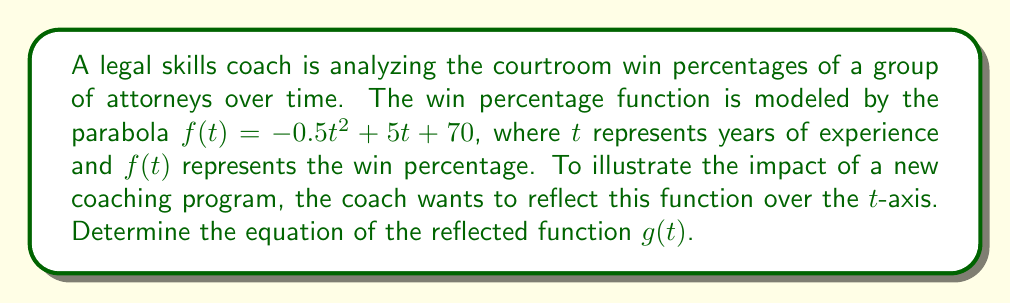Can you solve this math problem? To reflect the function $f(t) = -0.5t^2 + 5t + 70$ over the $t$-axis, we need to follow these steps:

1) The general form of a reflection over the $x$-axis (in this case, the $t$-axis) is $g(t) = -f(t)$.

2) Apply this transformation to our function:

   $g(t) = -(-0.5t^2 + 5t + 70)$

3) Distribute the negative sign:

   $g(t) = 0.5t^2 - 5t - 70$

4) The resulting function $g(t)$ represents the reflection of $f(t)$ over the $t$-axis.

This reflection effectively inverts the parabola, changing its orientation. In the context of the courtroom win percentages, this transformation could be interpreted as showing the "loss percentage" or the inverse of the original success rate over time.
Answer: $g(t) = 0.5t^2 - 5t - 70$ 